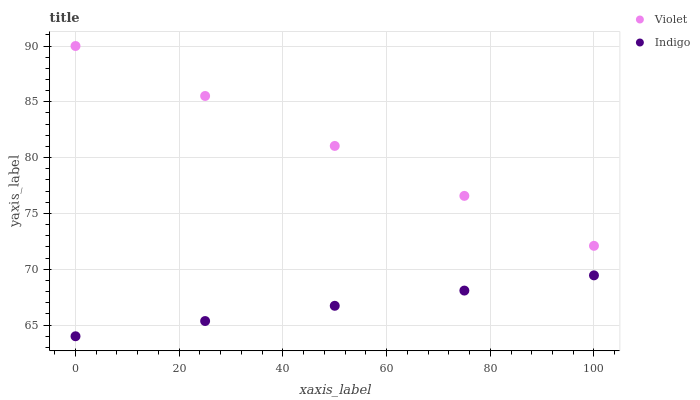Does Indigo have the minimum area under the curve?
Answer yes or no. Yes. Does Violet have the maximum area under the curve?
Answer yes or no. Yes. Does Violet have the minimum area under the curve?
Answer yes or no. No. Is Indigo the smoothest?
Answer yes or no. Yes. Is Violet the roughest?
Answer yes or no. Yes. Is Violet the smoothest?
Answer yes or no. No. Does Indigo have the lowest value?
Answer yes or no. Yes. Does Violet have the lowest value?
Answer yes or no. No. Does Violet have the highest value?
Answer yes or no. Yes. Is Indigo less than Violet?
Answer yes or no. Yes. Is Violet greater than Indigo?
Answer yes or no. Yes. Does Indigo intersect Violet?
Answer yes or no. No. 